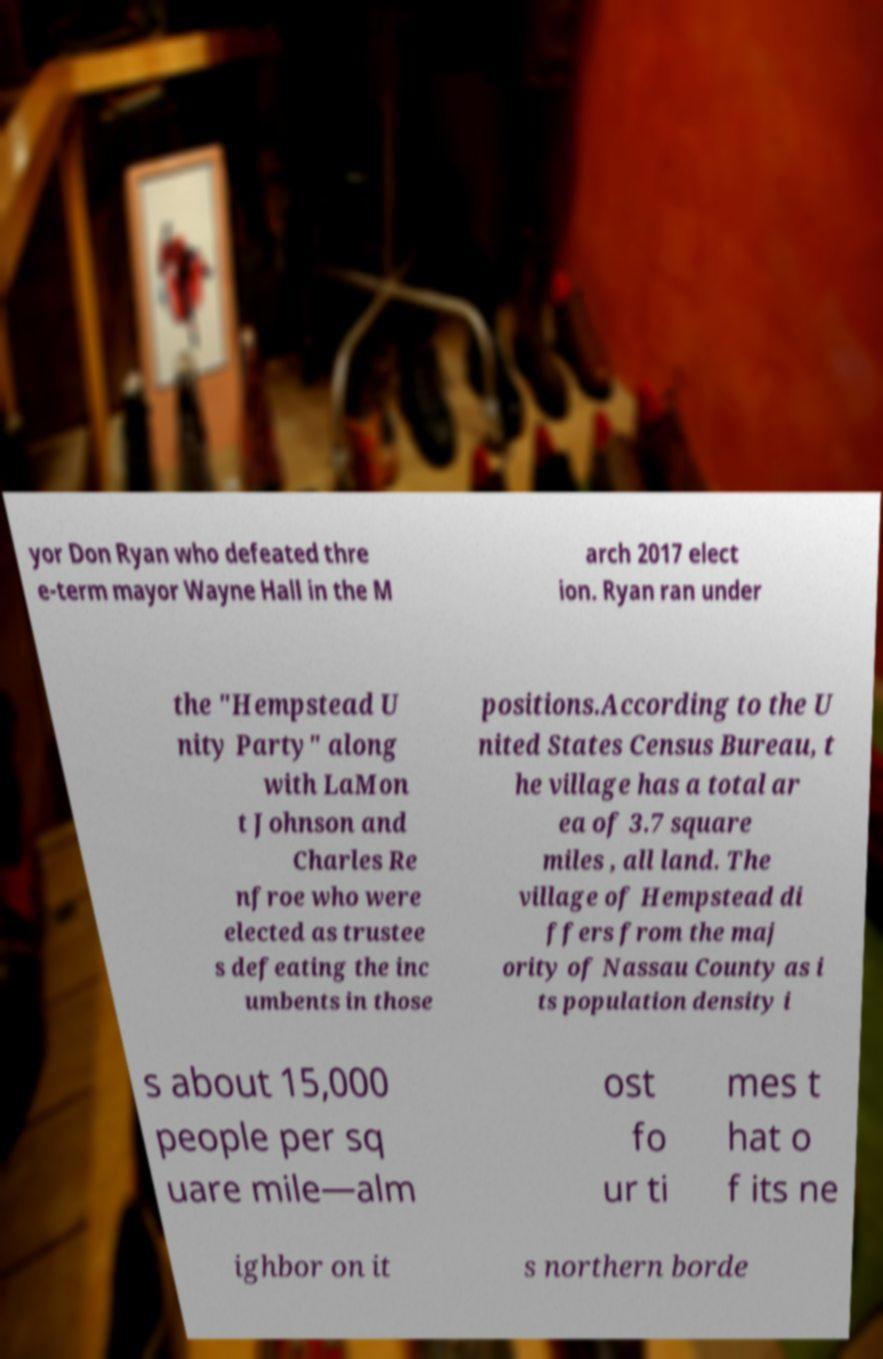There's text embedded in this image that I need extracted. Can you transcribe it verbatim? yor Don Ryan who defeated thre e-term mayor Wayne Hall in the M arch 2017 elect ion. Ryan ran under the "Hempstead U nity Party" along with LaMon t Johnson and Charles Re nfroe who were elected as trustee s defeating the inc umbents in those positions.According to the U nited States Census Bureau, t he village has a total ar ea of 3.7 square miles , all land. The village of Hempstead di ffers from the maj ority of Nassau County as i ts population density i s about 15,000 people per sq uare mile—alm ost fo ur ti mes t hat o f its ne ighbor on it s northern borde 